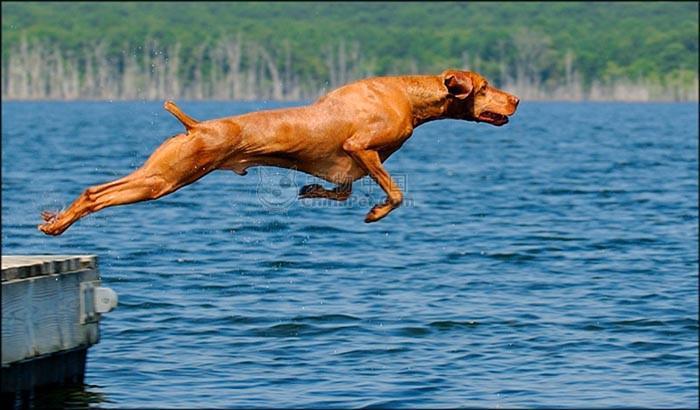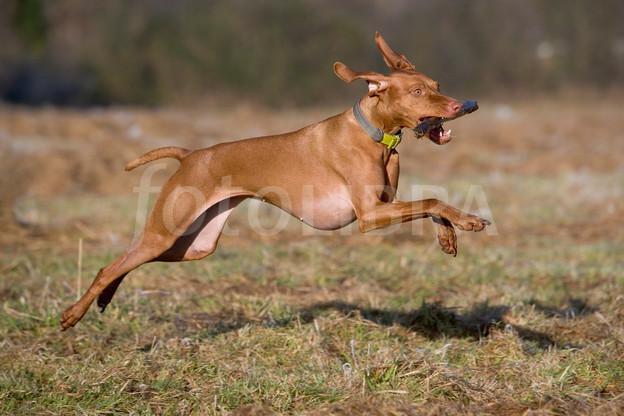The first image is the image on the left, the second image is the image on the right. Analyze the images presented: Is the assertion "No more than two dogs are visible." valid? Answer yes or no. Yes. The first image is the image on the left, the second image is the image on the right. For the images shown, is this caption "There are exactly two dogs." true? Answer yes or no. Yes. 